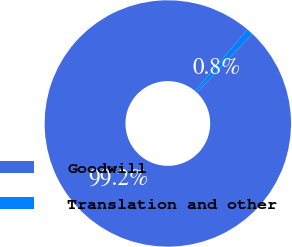Convert chart. <chart><loc_0><loc_0><loc_500><loc_500><pie_chart><fcel>Goodwill<fcel>Translation and other<nl><fcel>99.16%<fcel>0.84%<nl></chart> 